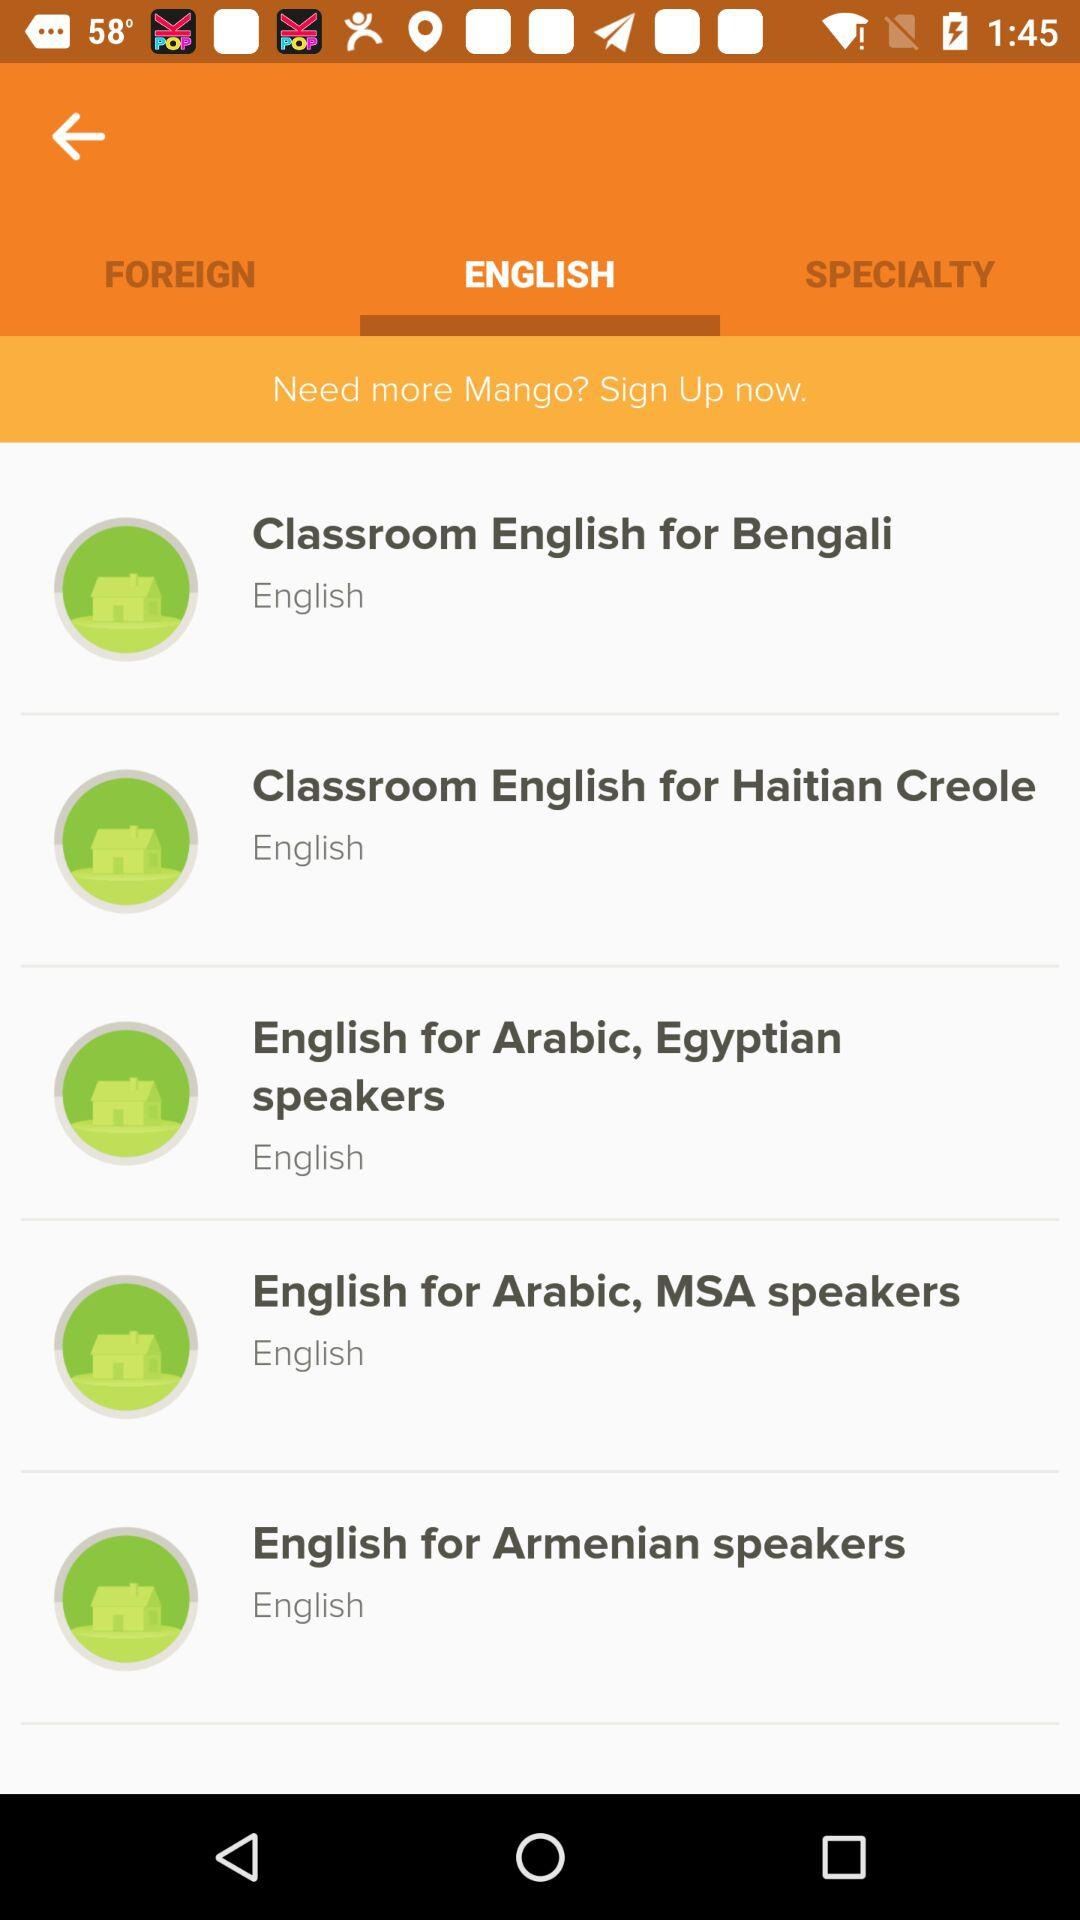Which tab is selected? The selected tab is "ENGLISH". 